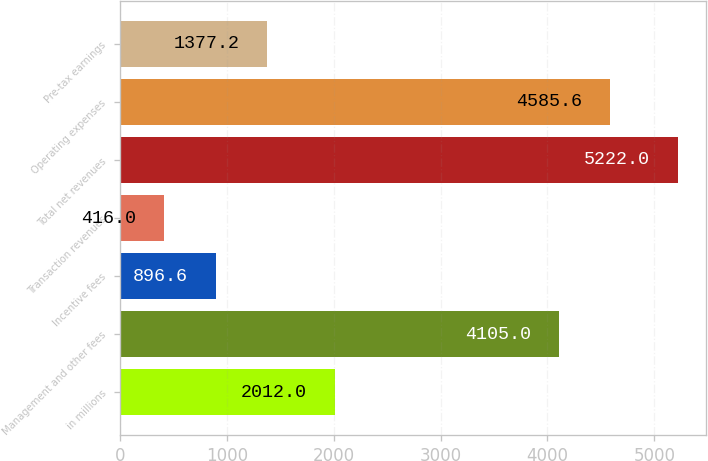Convert chart. <chart><loc_0><loc_0><loc_500><loc_500><bar_chart><fcel>in millions<fcel>Management and other fees<fcel>Incentive fees<fcel>Transaction revenues<fcel>Total net revenues<fcel>Operating expenses<fcel>Pre-tax earnings<nl><fcel>2012<fcel>4105<fcel>896.6<fcel>416<fcel>5222<fcel>4585.6<fcel>1377.2<nl></chart> 